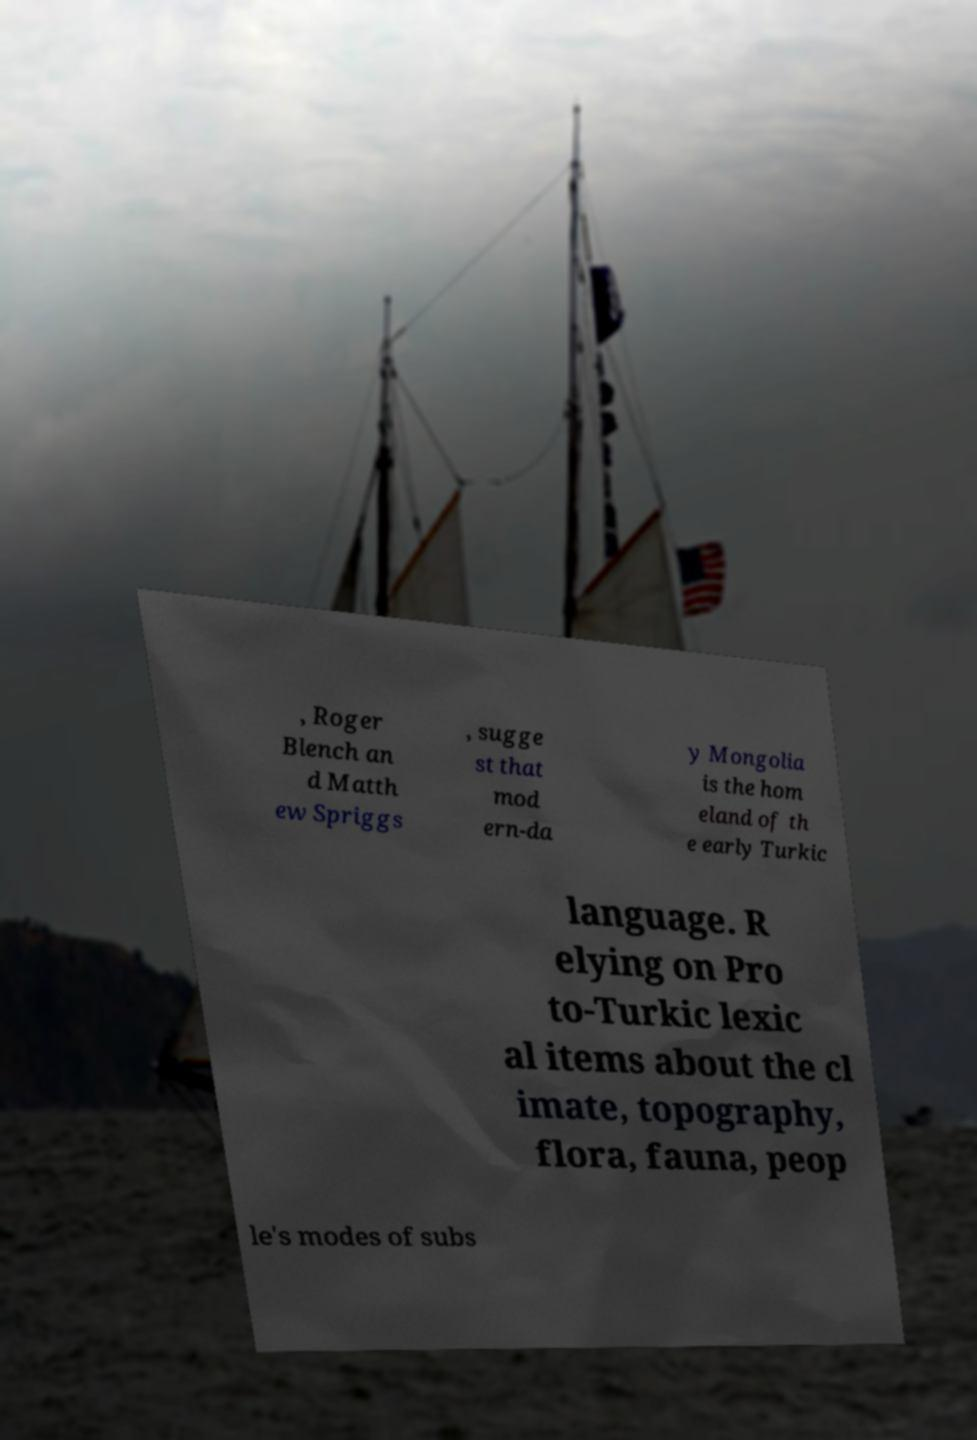There's text embedded in this image that I need extracted. Can you transcribe it verbatim? , Roger Blench an d Matth ew Spriggs , sugge st that mod ern-da y Mongolia is the hom eland of th e early Turkic language. R elying on Pro to-Turkic lexic al items about the cl imate, topography, flora, fauna, peop le's modes of subs 